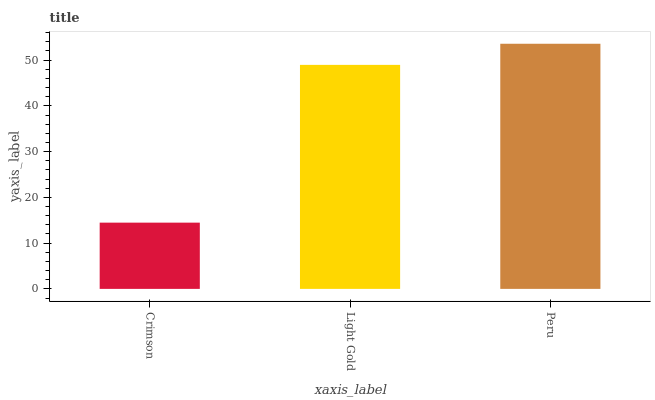Is Light Gold the minimum?
Answer yes or no. No. Is Light Gold the maximum?
Answer yes or no. No. Is Light Gold greater than Crimson?
Answer yes or no. Yes. Is Crimson less than Light Gold?
Answer yes or no. Yes. Is Crimson greater than Light Gold?
Answer yes or no. No. Is Light Gold less than Crimson?
Answer yes or no. No. Is Light Gold the high median?
Answer yes or no. Yes. Is Light Gold the low median?
Answer yes or no. Yes. Is Crimson the high median?
Answer yes or no. No. Is Crimson the low median?
Answer yes or no. No. 